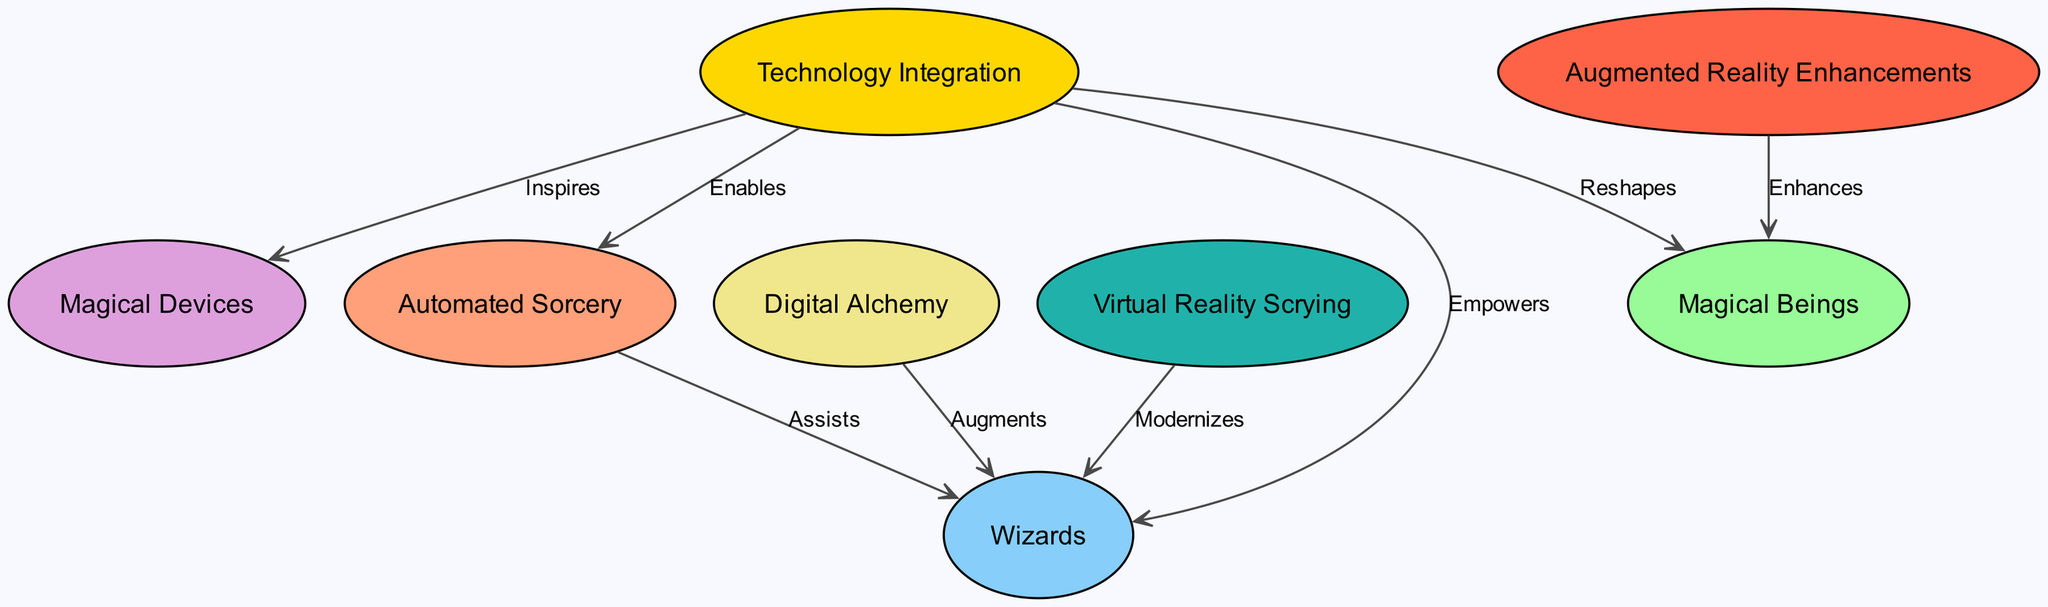What are the total number of nodes in the diagram? By counting each unique element in the "nodes" section of the data, we find there are eight distinct nodes: Technology Integration, Wizards, Magical Beings, Automated Sorcery, Magical Devices, Digital Alchemy, Virtual Reality Scrying, and Augmented Reality Enhancements.
Answer: 8 How many edges are present in the graph? The "edges" section lists connections between nodes; counting these gives us a total of seven edges that describe the relationships among the nodes.
Answer: 7 What is the label that connects Technology Integration to Wizards? The directed edge from Technology Integration to Wizards is labeled "Empowers", indicating the positive influence of technology on traditional wizards.
Answer: Empowers What role does Automated Sorcery play concerning Wizards? The directed edge shows that Automated Sorcery "Assists" Wizards, highlighting how automation can facilitate traditional magical practices.
Answer: Assists Which node is enhanced by Augmented Reality Enhancements? The edge originating from Augmented Reality Enhancements points to Magical Beings, signifying that AR enhancements provide additional capabilities or clarity to the magic associated with these beings.
Answer: Magical Beings How does Technology Integration affect Magical Devices? The connection from Technology Integration to Magical Devices is labeled "Inspires", indicating that the integration of technology serves as a source of creative influence or innovation for these devices.
Answer: Inspires What two nodes are directly affected by Digital Alchemy? Digital Alchemy directly connects to Wizards through the label "Augments", illustrating that it enhances traditional magical practices, but there are no outgoing edges indicating it affects any other nodes.
Answer: Wizards In what way is Virtual Reality Scrying related to Wizards? The directed edge from Virtual Reality Scrying to Wizards is labeled "Modernizes", which means that VR tools bring contemporary techniques to traditional divination practices done by wizards.
Answer: Modernizes 